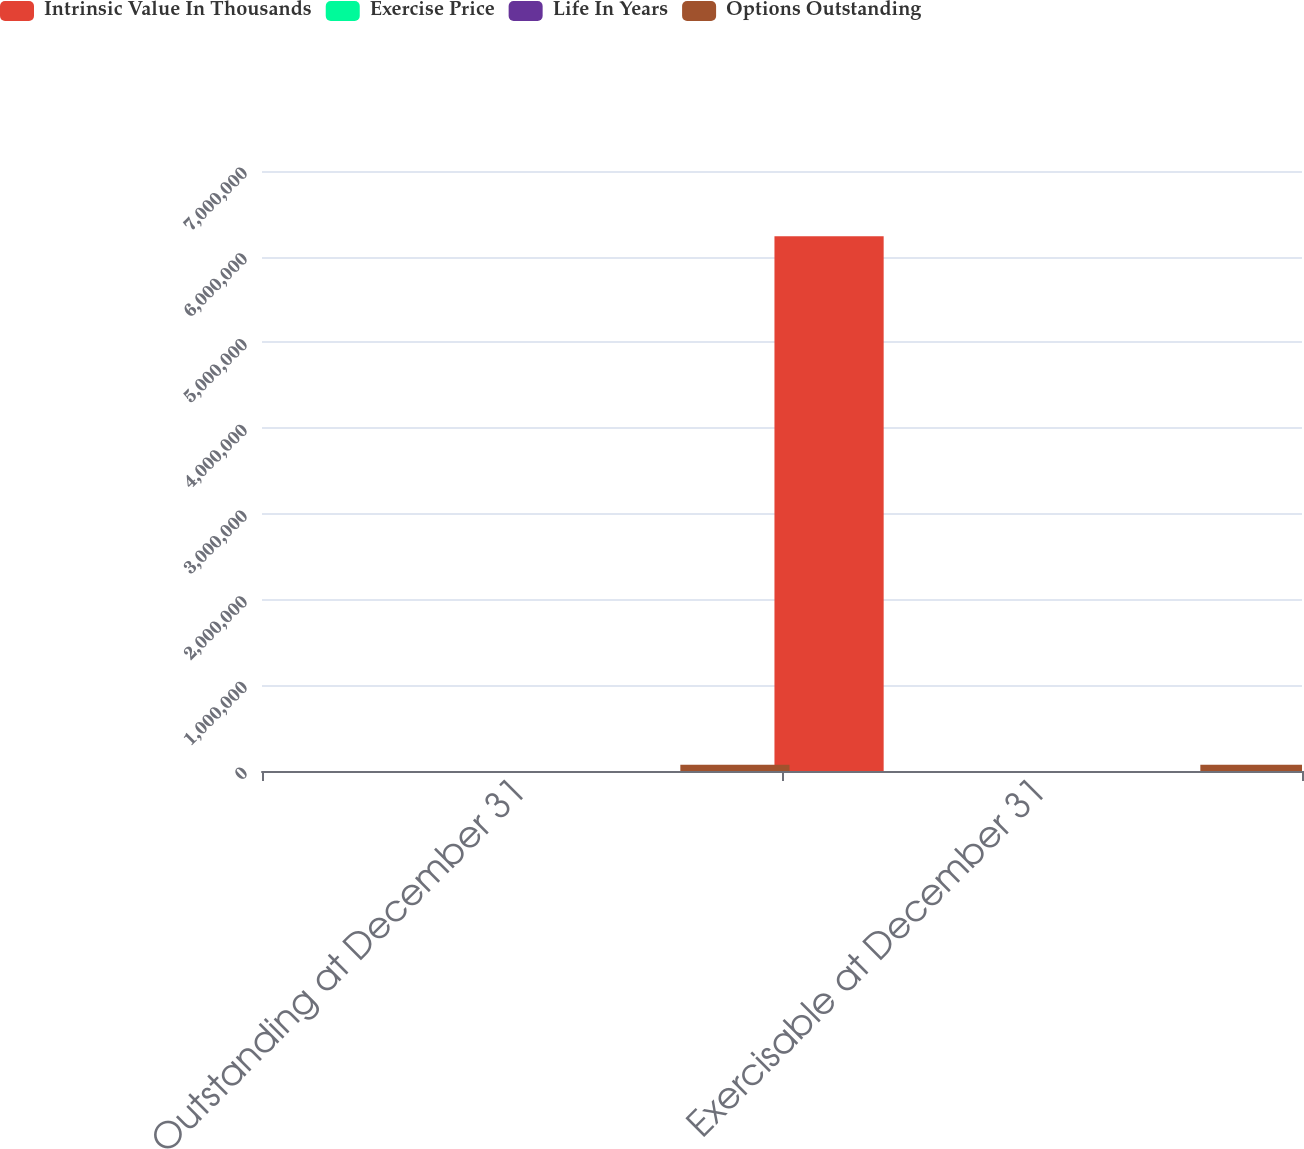<chart> <loc_0><loc_0><loc_500><loc_500><stacked_bar_chart><ecel><fcel>Outstanding at December 31<fcel>Exercisable at December 31<nl><fcel>Intrinsic Value In Thousands<fcel>88.95<fcel>6.23916e+06<nl><fcel>Exercise Price<fcel>88.95<fcel>73.39<nl><fcel>Life In Years<fcel>5.8<fcel>4.1<nl><fcel>Options Outstanding<fcel>72990<fcel>72990<nl></chart> 